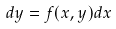Convert formula to latex. <formula><loc_0><loc_0><loc_500><loc_500>d y = f ( x , y ) d x</formula> 